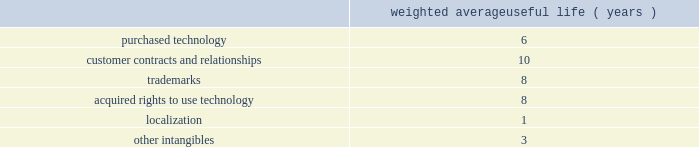Adobe systems incorporated notes to consolidated financial statements ( continued ) we review our goodwill for impairment annually , or more frequently , if facts and circumstances warrant a review .
We completed our annual impairment test in the second quarter of fiscal 2013 .
We elected to use the step 1 quantitative assessment for our three reporting units 2014digital media , digital marketing and print and publishing 2014and determined that there was no impairment of goodwill .
There is no significant risk of material goodwill impairment in any of our reporting units , based upon the results of our annual goodwill impairment test .
We amortize intangible assets with finite lives over their estimated useful lives and review them for impairment whenever an impairment indicator exists .
We continually monitor events and changes in circumstances that could indicate carrying amounts of our long-lived assets , including our intangible assets may not be recoverable .
When such events or changes in circumstances occur , we assess recoverability by determining whether the carrying value of such assets will be recovered through the undiscounted expected future cash flows .
If the future undiscounted cash flows are less than the carrying amount of these assets , we recognize an impairment loss based on any excess of the carrying amount over the fair value of the assets .
We did not recognize any intangible asset impairment charges in fiscal 2013 , 2012 or 2011 .
Our intangible assets are amortized over their estimated useful lives of 1 to 14 years .
Amortization is based on the pattern in which the economic benefits of the intangible asset will be consumed or on a straight-line basis when the consumption pattern is not apparent .
The weighted average useful lives of our intangible assets were as follows : weighted average useful life ( years ) .
Software development costs capitalization of software development costs for software to be sold , leased , or otherwise marketed begins upon the establishment of technological feasibility , which is generally the completion of a working prototype that has been certified as having no critical bugs and is a release candidate .
Amortization begins once the software is ready for its intended use , generally based on the pattern in which the economic benefits will be consumed .
To date , software development costs incurred between completion of a working prototype and general availability of the related product have not been material .
Internal use software we capitalize costs associated with customized internal-use software systems that have reached the application development stage .
Such capitalized costs include external direct costs utilized in developing or obtaining the applications and payroll and payroll-related expenses for employees , who are directly associated with the development of the applications .
Capitalization of such costs begins when the preliminary project stage is complete and ceases at the point in which the project is substantially complete and is ready for its intended purpose .
Income taxes we use the asset and liability method of accounting for income taxes .
Under this method , income tax expense is recognized for the amount of taxes payable or refundable for the current year .
In addition , deferred tax assets and liabilities are recognized for expected future tax consequences of temporary differences between the financial reporting and tax bases of assets and liabilities , and for operating losses and tax credit carryforwards .
We record a valuation allowance to reduce deferred tax assets to an amount for which realization is more likely than not. .
What is the average weighted average useful life ( years ) for purchased technology and customer contracts and relationships? 
Computations: ((6 + 10) / 2)
Answer: 8.0. Adobe systems incorporated notes to consolidated financial statements ( continued ) we review our goodwill for impairment annually , or more frequently , if facts and circumstances warrant a review .
We completed our annual impairment test in the second quarter of fiscal 2014 .
We elected to use the step 1 quantitative assessment for our reporting units and determined that there was no impairment of goodwill .
There is no significant risk of material goodwill impairment in any of our reporting units , based upon the results of our annual goodwill impairment test .
We amortize intangible assets with finite lives over their estimated useful lives and review them for impairment whenever an impairment indicator exists .
We continually monitor events and changes in circumstances that could indicate carrying amounts of our long-lived assets , including our intangible assets may not be recoverable .
When such events or changes in circumstances occur , we assess recoverability by determining whether the carrying value of such assets will be recovered through the undiscounted expected future cash flows .
If the future undiscounted cash flows are less than the carrying amount of these assets , we recognize an impairment loss based on any excess of the carrying amount over the fair value of the assets .
We did not recognize any intangible asset impairment charges in fiscal 2014 , 2013 or 2012 .
Our intangible assets are amortized over their estimated useful lives of 1 to 14 years .
Amortization is based on the pattern in which the economic benefits of the intangible asset will be consumed or on a straight-line basis when the consumption pattern is not apparent .
The weighted average useful lives of our intangible assets were as follows : weighted average useful life ( years ) .
Software development costs capitalization of software development costs for software to be sold , leased , or otherwise marketed begins upon the establishment of technological feasibility , which is generally the completion of a working prototype that has been certified as having no critical bugs and is a release candidate .
Amortization begins once the software is ready for its intended use , generally based on the pattern in which the economic benefits will be consumed .
To date , software development costs incurred between completion of a working prototype and general availability of the related product have not been material .
Internal use software we capitalize costs associated with customized internal-use software systems that have reached the application development stage .
Such capitalized costs include external direct costs utilized in developing or obtaining the applications and payroll and payroll-related expenses for employees , who are directly associated with the development of the applications .
Capitalization of such costs begins when the preliminary project stage is complete and ceases at the point in which the project is substantially complete and is ready for its intended purpose .
Income taxes we use the asset and liability method of accounting for income taxes .
Under this method , income tax expense is recognized for the amount of taxes payable or refundable for the current year .
In addition , deferred tax assets and liabilities are recognized for expected future tax consequences of temporary differences between the financial reporting and tax bases of assets and liabilities , and for operating losses and tax credit carryforwards .
We record a valuation allowance to reduce deferred tax assets to an amount for which realization is more likely than not .
Taxes collected from customers we net taxes collected from customers against those remitted to government authorities in our financial statements .
Accordingly , taxes collected from customers are not reported as revenue. .
What is the yearly amortization rate related to the purchased technology? 
Computations: (100 / 6)
Answer: 16.66667. 